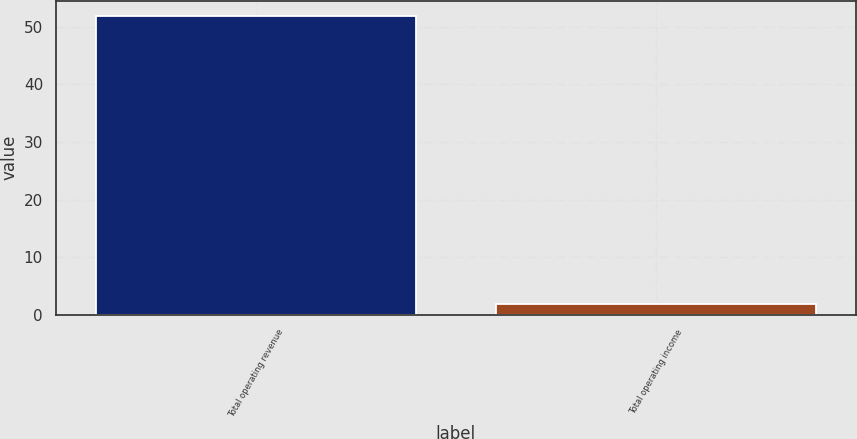<chart> <loc_0><loc_0><loc_500><loc_500><bar_chart><fcel>Total operating revenue<fcel>Total operating income<nl><fcel>51.9<fcel>1.8<nl></chart> 